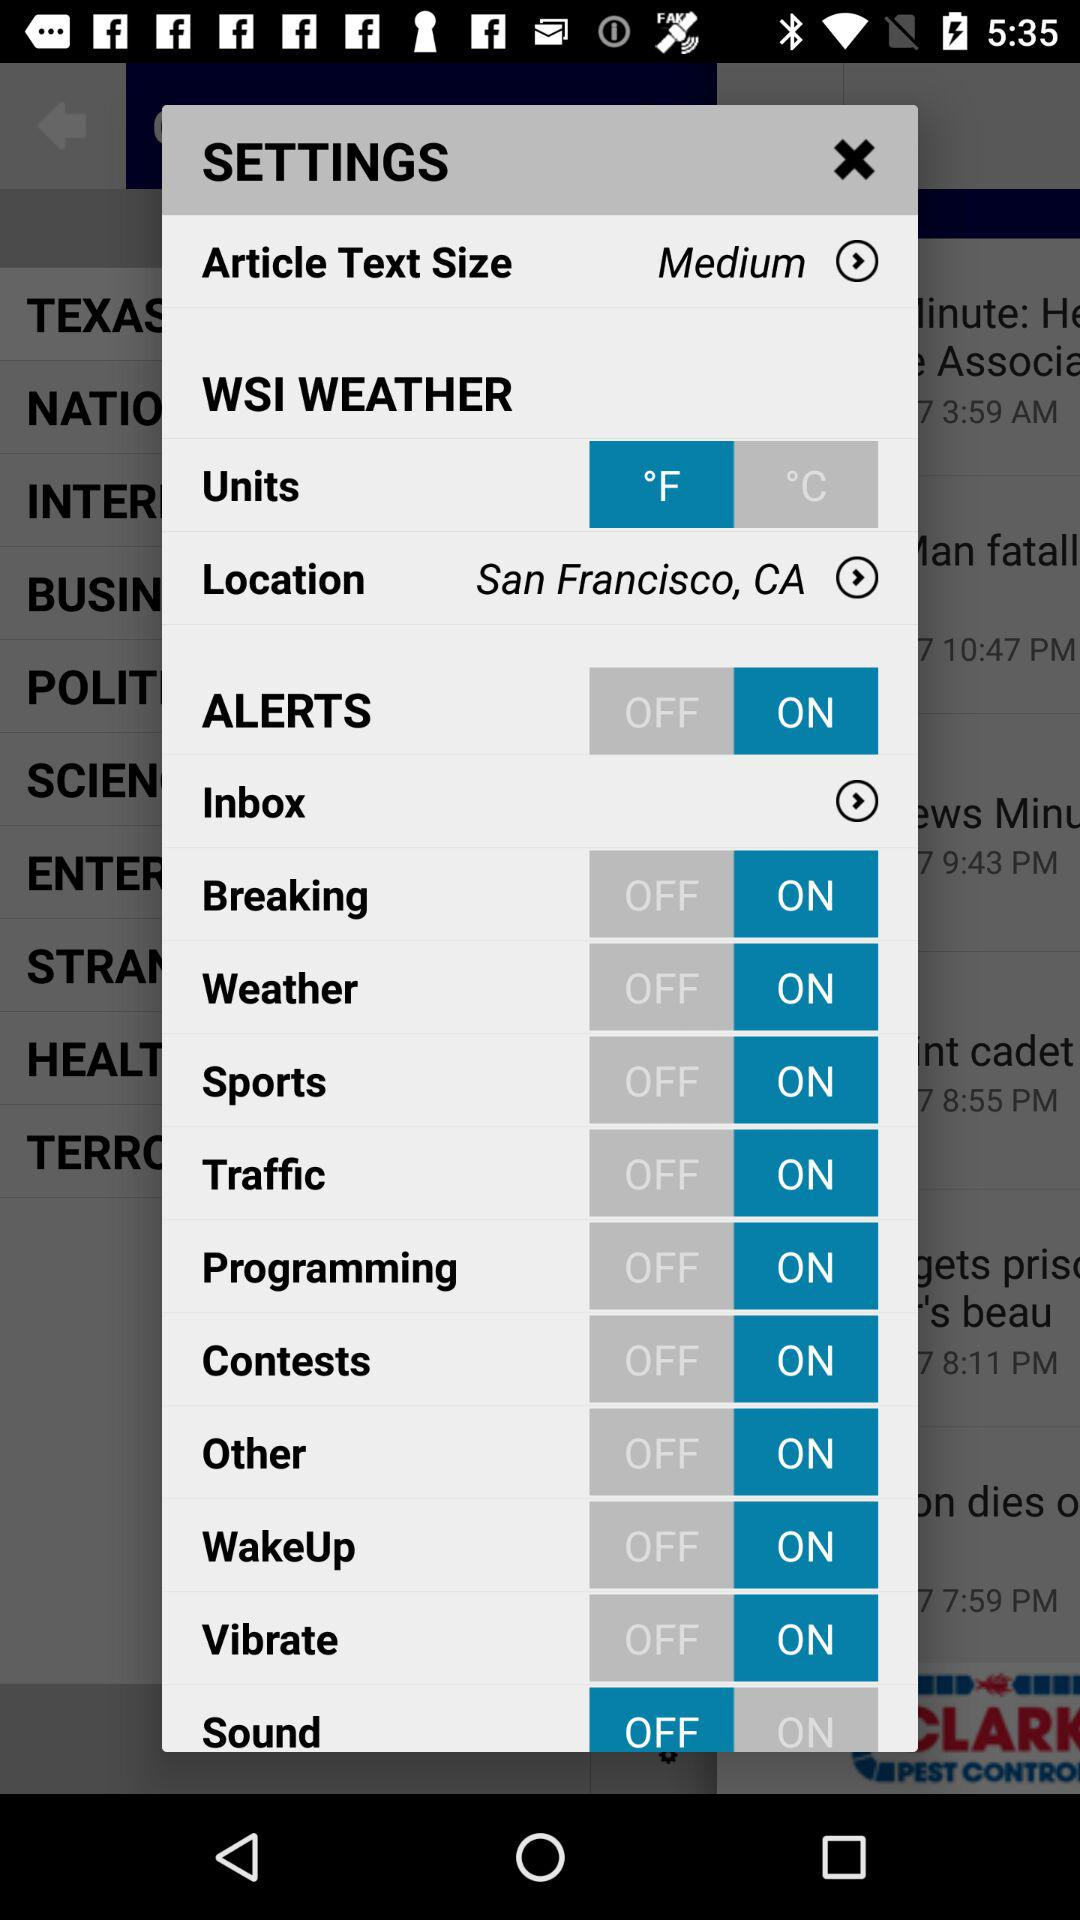What is the status of the "Traffic" setting? The status is "on". 